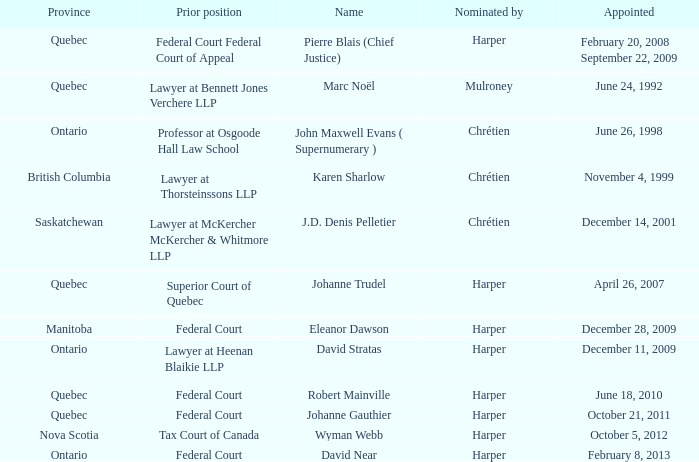Who was appointed on October 21, 2011 from Quebec? Johanne Gauthier. 